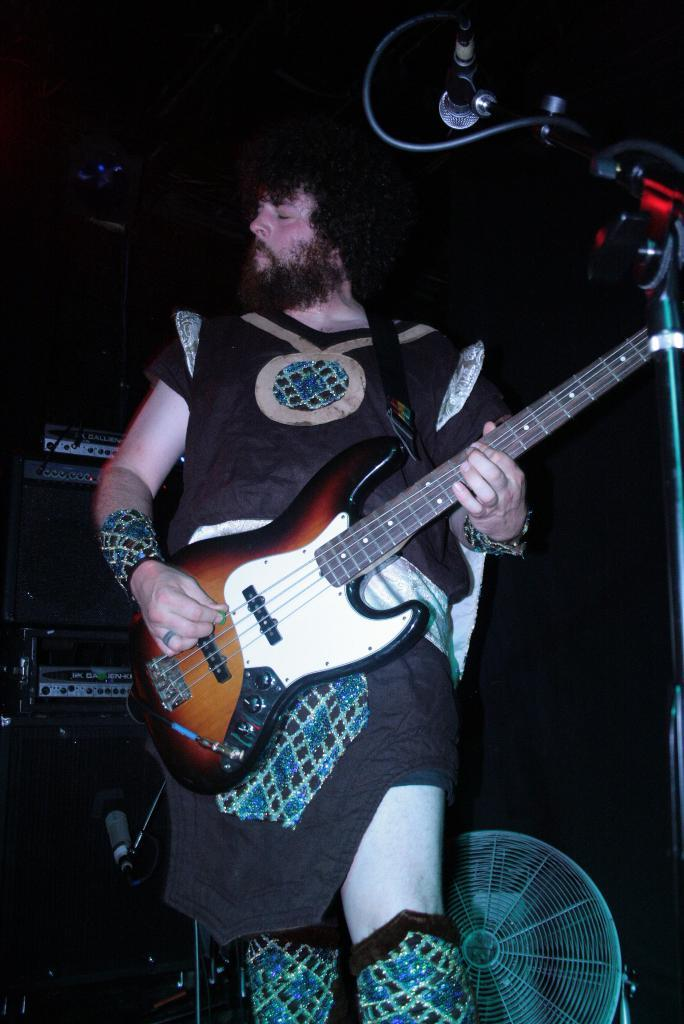Who is present in the image? There is a man in the image. What is the man doing in the image? The man is standing in the image. What object is the man holding in the image? The man is holding a guitar in the image. What is the man wearing in the image? The man is wearing a costume in the image. What other object can be seen in the image? There is a microphone in the image. How much wealth does the lettuce in the image possess? There is no lettuce present in the image, so it is not possible to determine its wealth. 